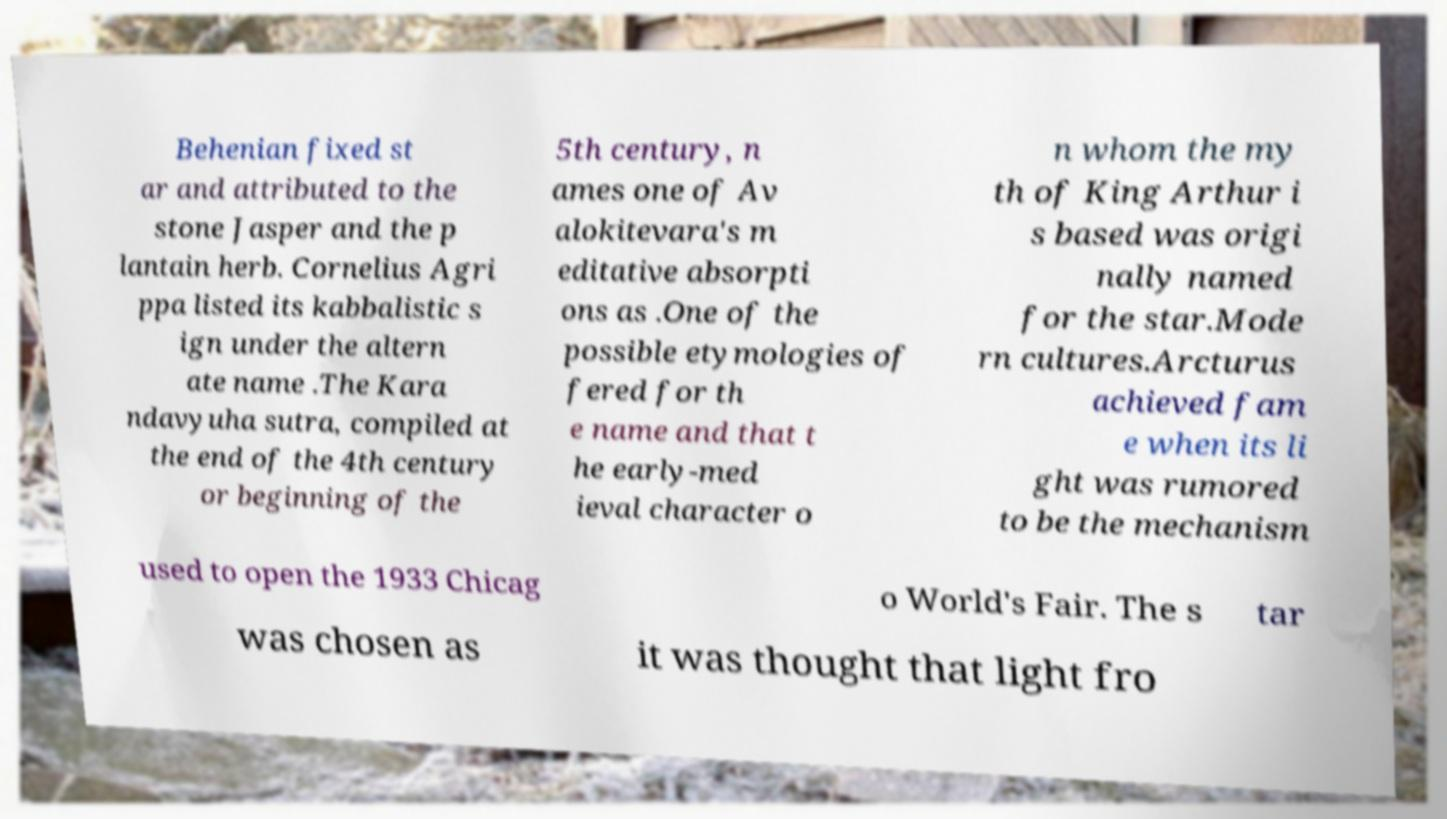Could you assist in decoding the text presented in this image and type it out clearly? Behenian fixed st ar and attributed to the stone Jasper and the p lantain herb. Cornelius Agri ppa listed its kabbalistic s ign under the altern ate name .The Kara ndavyuha sutra, compiled at the end of the 4th century or beginning of the 5th century, n ames one of Av alokitevara's m editative absorpti ons as .One of the possible etymologies of fered for th e name and that t he early-med ieval character o n whom the my th of King Arthur i s based was origi nally named for the star.Mode rn cultures.Arcturus achieved fam e when its li ght was rumored to be the mechanism used to open the 1933 Chicag o World's Fair. The s tar was chosen as it was thought that light fro 